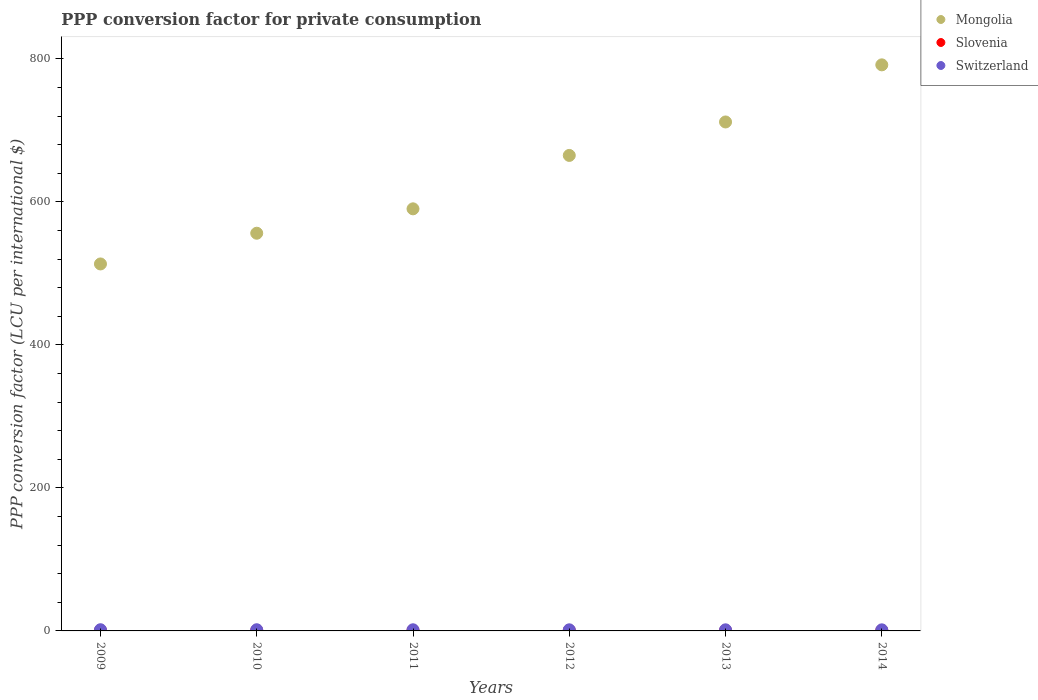What is the PPP conversion factor for private consumption in Slovenia in 2012?
Offer a terse response. 0.68. Across all years, what is the maximum PPP conversion factor for private consumption in Mongolia?
Make the answer very short. 791.69. Across all years, what is the minimum PPP conversion factor for private consumption in Slovenia?
Keep it short and to the point. 0.67. What is the total PPP conversion factor for private consumption in Mongolia in the graph?
Provide a succinct answer. 3828.33. What is the difference between the PPP conversion factor for private consumption in Switzerland in 2009 and that in 2010?
Give a very brief answer. 0.01. What is the difference between the PPP conversion factor for private consumption in Mongolia in 2013 and the PPP conversion factor for private consumption in Switzerland in 2012?
Give a very brief answer. 710.27. What is the average PPP conversion factor for private consumption in Slovenia per year?
Keep it short and to the point. 0.68. In the year 2011, what is the difference between the PPP conversion factor for private consumption in Switzerland and PPP conversion factor for private consumption in Slovenia?
Your answer should be very brief. 0.9. What is the ratio of the PPP conversion factor for private consumption in Switzerland in 2012 to that in 2014?
Offer a very short reply. 1.02. Is the PPP conversion factor for private consumption in Switzerland in 2010 less than that in 2013?
Keep it short and to the point. No. Is the difference between the PPP conversion factor for private consumption in Switzerland in 2010 and 2014 greater than the difference between the PPP conversion factor for private consumption in Slovenia in 2010 and 2014?
Your answer should be very brief. Yes. What is the difference between the highest and the second highest PPP conversion factor for private consumption in Mongolia?
Your answer should be compact. 79.87. What is the difference between the highest and the lowest PPP conversion factor for private consumption in Slovenia?
Provide a short and direct response. 0.04. Is the sum of the PPP conversion factor for private consumption in Mongolia in 2010 and 2014 greater than the maximum PPP conversion factor for private consumption in Switzerland across all years?
Your answer should be compact. Yes. Is it the case that in every year, the sum of the PPP conversion factor for private consumption in Slovenia and PPP conversion factor for private consumption in Switzerland  is greater than the PPP conversion factor for private consumption in Mongolia?
Offer a very short reply. No. How many dotlines are there?
Your answer should be compact. 3. How many years are there in the graph?
Provide a short and direct response. 6. Does the graph contain any zero values?
Provide a succinct answer. No. Does the graph contain grids?
Provide a short and direct response. No. Where does the legend appear in the graph?
Make the answer very short. Top right. How many legend labels are there?
Offer a very short reply. 3. What is the title of the graph?
Your answer should be compact. PPP conversion factor for private consumption. What is the label or title of the Y-axis?
Your answer should be very brief. PPP conversion factor (LCU per international $). What is the PPP conversion factor (LCU per international $) of Mongolia in 2009?
Keep it short and to the point. 513.24. What is the PPP conversion factor (LCU per international $) of Slovenia in 2009?
Provide a succinct answer. 0.7. What is the PPP conversion factor (LCU per international $) of Switzerland in 2009?
Provide a succinct answer. 1.67. What is the PPP conversion factor (LCU per international $) in Mongolia in 2010?
Your response must be concise. 556.21. What is the PPP conversion factor (LCU per international $) of Slovenia in 2010?
Keep it short and to the point. 0.7. What is the PPP conversion factor (LCU per international $) of Switzerland in 2010?
Offer a very short reply. 1.66. What is the PPP conversion factor (LCU per international $) in Mongolia in 2011?
Your answer should be compact. 590.33. What is the PPP conversion factor (LCU per international $) of Slovenia in 2011?
Keep it short and to the point. 0.69. What is the PPP conversion factor (LCU per international $) of Switzerland in 2011?
Make the answer very short. 1.59. What is the PPP conversion factor (LCU per international $) in Mongolia in 2012?
Your answer should be very brief. 665.03. What is the PPP conversion factor (LCU per international $) in Slovenia in 2012?
Offer a very short reply. 0.68. What is the PPP conversion factor (LCU per international $) of Switzerland in 2012?
Provide a short and direct response. 1.55. What is the PPP conversion factor (LCU per international $) of Mongolia in 2013?
Offer a terse response. 711.82. What is the PPP conversion factor (LCU per international $) in Slovenia in 2013?
Your answer should be very brief. 0.67. What is the PPP conversion factor (LCU per international $) in Switzerland in 2013?
Provide a succinct answer. 1.54. What is the PPP conversion factor (LCU per international $) of Mongolia in 2014?
Your response must be concise. 791.69. What is the PPP conversion factor (LCU per international $) of Slovenia in 2014?
Ensure brevity in your answer.  0.67. What is the PPP conversion factor (LCU per international $) in Switzerland in 2014?
Your answer should be very brief. 1.52. Across all years, what is the maximum PPP conversion factor (LCU per international $) in Mongolia?
Ensure brevity in your answer.  791.69. Across all years, what is the maximum PPP conversion factor (LCU per international $) in Slovenia?
Your answer should be compact. 0.7. Across all years, what is the maximum PPP conversion factor (LCU per international $) in Switzerland?
Your answer should be very brief. 1.67. Across all years, what is the minimum PPP conversion factor (LCU per international $) in Mongolia?
Make the answer very short. 513.24. Across all years, what is the minimum PPP conversion factor (LCU per international $) of Slovenia?
Your response must be concise. 0.67. Across all years, what is the minimum PPP conversion factor (LCU per international $) of Switzerland?
Make the answer very short. 1.52. What is the total PPP conversion factor (LCU per international $) of Mongolia in the graph?
Your answer should be compact. 3828.33. What is the total PPP conversion factor (LCU per international $) of Slovenia in the graph?
Your response must be concise. 4.11. What is the total PPP conversion factor (LCU per international $) of Switzerland in the graph?
Your answer should be very brief. 9.52. What is the difference between the PPP conversion factor (LCU per international $) of Mongolia in 2009 and that in 2010?
Offer a very short reply. -42.97. What is the difference between the PPP conversion factor (LCU per international $) of Slovenia in 2009 and that in 2010?
Give a very brief answer. 0.01. What is the difference between the PPP conversion factor (LCU per international $) of Switzerland in 2009 and that in 2010?
Keep it short and to the point. 0.01. What is the difference between the PPP conversion factor (LCU per international $) in Mongolia in 2009 and that in 2011?
Provide a succinct answer. -77.09. What is the difference between the PPP conversion factor (LCU per international $) of Slovenia in 2009 and that in 2011?
Provide a short and direct response. 0.02. What is the difference between the PPP conversion factor (LCU per international $) in Switzerland in 2009 and that in 2011?
Your answer should be very brief. 0.08. What is the difference between the PPP conversion factor (LCU per international $) of Mongolia in 2009 and that in 2012?
Keep it short and to the point. -151.78. What is the difference between the PPP conversion factor (LCU per international $) in Slovenia in 2009 and that in 2012?
Offer a very short reply. 0.03. What is the difference between the PPP conversion factor (LCU per international $) in Switzerland in 2009 and that in 2012?
Provide a short and direct response. 0.11. What is the difference between the PPP conversion factor (LCU per international $) in Mongolia in 2009 and that in 2013?
Offer a very short reply. -198.58. What is the difference between the PPP conversion factor (LCU per international $) in Slovenia in 2009 and that in 2013?
Ensure brevity in your answer.  0.03. What is the difference between the PPP conversion factor (LCU per international $) in Switzerland in 2009 and that in 2013?
Provide a short and direct response. 0.12. What is the difference between the PPP conversion factor (LCU per international $) of Mongolia in 2009 and that in 2014?
Provide a succinct answer. -278.45. What is the difference between the PPP conversion factor (LCU per international $) in Slovenia in 2009 and that in 2014?
Offer a very short reply. 0.04. What is the difference between the PPP conversion factor (LCU per international $) in Mongolia in 2010 and that in 2011?
Provide a succinct answer. -34.12. What is the difference between the PPP conversion factor (LCU per international $) in Slovenia in 2010 and that in 2011?
Ensure brevity in your answer.  0.01. What is the difference between the PPP conversion factor (LCU per international $) of Switzerland in 2010 and that in 2011?
Your answer should be compact. 0.07. What is the difference between the PPP conversion factor (LCU per international $) of Mongolia in 2010 and that in 2012?
Offer a very short reply. -108.81. What is the difference between the PPP conversion factor (LCU per international $) of Slovenia in 2010 and that in 2012?
Provide a short and direct response. 0.02. What is the difference between the PPP conversion factor (LCU per international $) of Switzerland in 2010 and that in 2012?
Make the answer very short. 0.11. What is the difference between the PPP conversion factor (LCU per international $) in Mongolia in 2010 and that in 2013?
Give a very brief answer. -155.61. What is the difference between the PPP conversion factor (LCU per international $) in Slovenia in 2010 and that in 2013?
Provide a succinct answer. 0.03. What is the difference between the PPP conversion factor (LCU per international $) in Switzerland in 2010 and that in 2013?
Keep it short and to the point. 0.12. What is the difference between the PPP conversion factor (LCU per international $) of Mongolia in 2010 and that in 2014?
Offer a very short reply. -235.48. What is the difference between the PPP conversion factor (LCU per international $) of Slovenia in 2010 and that in 2014?
Make the answer very short. 0.03. What is the difference between the PPP conversion factor (LCU per international $) of Switzerland in 2010 and that in 2014?
Your answer should be very brief. 0.14. What is the difference between the PPP conversion factor (LCU per international $) in Mongolia in 2011 and that in 2012?
Offer a very short reply. -74.7. What is the difference between the PPP conversion factor (LCU per international $) in Slovenia in 2011 and that in 2012?
Give a very brief answer. 0.01. What is the difference between the PPP conversion factor (LCU per international $) of Switzerland in 2011 and that in 2012?
Offer a very short reply. 0.03. What is the difference between the PPP conversion factor (LCU per international $) in Mongolia in 2011 and that in 2013?
Provide a short and direct response. -121.49. What is the difference between the PPP conversion factor (LCU per international $) in Slovenia in 2011 and that in 2013?
Your answer should be very brief. 0.01. What is the difference between the PPP conversion factor (LCU per international $) of Switzerland in 2011 and that in 2013?
Provide a short and direct response. 0.05. What is the difference between the PPP conversion factor (LCU per international $) in Mongolia in 2011 and that in 2014?
Your answer should be very brief. -201.36. What is the difference between the PPP conversion factor (LCU per international $) of Slovenia in 2011 and that in 2014?
Ensure brevity in your answer.  0.02. What is the difference between the PPP conversion factor (LCU per international $) of Switzerland in 2011 and that in 2014?
Keep it short and to the point. 0.07. What is the difference between the PPP conversion factor (LCU per international $) of Mongolia in 2012 and that in 2013?
Make the answer very short. -46.8. What is the difference between the PPP conversion factor (LCU per international $) in Slovenia in 2012 and that in 2013?
Offer a terse response. 0. What is the difference between the PPP conversion factor (LCU per international $) in Switzerland in 2012 and that in 2013?
Provide a succinct answer. 0.01. What is the difference between the PPP conversion factor (LCU per international $) of Mongolia in 2012 and that in 2014?
Offer a terse response. -126.67. What is the difference between the PPP conversion factor (LCU per international $) in Slovenia in 2012 and that in 2014?
Provide a short and direct response. 0.01. What is the difference between the PPP conversion factor (LCU per international $) of Switzerland in 2012 and that in 2014?
Offer a terse response. 0.04. What is the difference between the PPP conversion factor (LCU per international $) of Mongolia in 2013 and that in 2014?
Keep it short and to the point. -79.87. What is the difference between the PPP conversion factor (LCU per international $) of Slovenia in 2013 and that in 2014?
Provide a succinct answer. 0.01. What is the difference between the PPP conversion factor (LCU per international $) in Switzerland in 2013 and that in 2014?
Your response must be concise. 0.03. What is the difference between the PPP conversion factor (LCU per international $) in Mongolia in 2009 and the PPP conversion factor (LCU per international $) in Slovenia in 2010?
Offer a very short reply. 512.54. What is the difference between the PPP conversion factor (LCU per international $) in Mongolia in 2009 and the PPP conversion factor (LCU per international $) in Switzerland in 2010?
Keep it short and to the point. 511.58. What is the difference between the PPP conversion factor (LCU per international $) of Slovenia in 2009 and the PPP conversion factor (LCU per international $) of Switzerland in 2010?
Make the answer very short. -0.95. What is the difference between the PPP conversion factor (LCU per international $) in Mongolia in 2009 and the PPP conversion factor (LCU per international $) in Slovenia in 2011?
Keep it short and to the point. 512.56. What is the difference between the PPP conversion factor (LCU per international $) in Mongolia in 2009 and the PPP conversion factor (LCU per international $) in Switzerland in 2011?
Your response must be concise. 511.66. What is the difference between the PPP conversion factor (LCU per international $) in Slovenia in 2009 and the PPP conversion factor (LCU per international $) in Switzerland in 2011?
Make the answer very short. -0.88. What is the difference between the PPP conversion factor (LCU per international $) of Mongolia in 2009 and the PPP conversion factor (LCU per international $) of Slovenia in 2012?
Provide a succinct answer. 512.57. What is the difference between the PPP conversion factor (LCU per international $) of Mongolia in 2009 and the PPP conversion factor (LCU per international $) of Switzerland in 2012?
Offer a very short reply. 511.69. What is the difference between the PPP conversion factor (LCU per international $) of Slovenia in 2009 and the PPP conversion factor (LCU per international $) of Switzerland in 2012?
Your answer should be very brief. -0.85. What is the difference between the PPP conversion factor (LCU per international $) in Mongolia in 2009 and the PPP conversion factor (LCU per international $) in Slovenia in 2013?
Your answer should be compact. 512.57. What is the difference between the PPP conversion factor (LCU per international $) in Mongolia in 2009 and the PPP conversion factor (LCU per international $) in Switzerland in 2013?
Your answer should be very brief. 511.7. What is the difference between the PPP conversion factor (LCU per international $) in Slovenia in 2009 and the PPP conversion factor (LCU per international $) in Switzerland in 2013?
Your answer should be very brief. -0.84. What is the difference between the PPP conversion factor (LCU per international $) of Mongolia in 2009 and the PPP conversion factor (LCU per international $) of Slovenia in 2014?
Ensure brevity in your answer.  512.58. What is the difference between the PPP conversion factor (LCU per international $) of Mongolia in 2009 and the PPP conversion factor (LCU per international $) of Switzerland in 2014?
Offer a very short reply. 511.73. What is the difference between the PPP conversion factor (LCU per international $) in Slovenia in 2009 and the PPP conversion factor (LCU per international $) in Switzerland in 2014?
Your answer should be very brief. -0.81. What is the difference between the PPP conversion factor (LCU per international $) in Mongolia in 2010 and the PPP conversion factor (LCU per international $) in Slovenia in 2011?
Offer a very short reply. 555.53. What is the difference between the PPP conversion factor (LCU per international $) in Mongolia in 2010 and the PPP conversion factor (LCU per international $) in Switzerland in 2011?
Offer a very short reply. 554.63. What is the difference between the PPP conversion factor (LCU per international $) in Slovenia in 2010 and the PPP conversion factor (LCU per international $) in Switzerland in 2011?
Provide a short and direct response. -0.89. What is the difference between the PPP conversion factor (LCU per international $) of Mongolia in 2010 and the PPP conversion factor (LCU per international $) of Slovenia in 2012?
Your answer should be compact. 555.54. What is the difference between the PPP conversion factor (LCU per international $) in Mongolia in 2010 and the PPP conversion factor (LCU per international $) in Switzerland in 2012?
Ensure brevity in your answer.  554.66. What is the difference between the PPP conversion factor (LCU per international $) in Slovenia in 2010 and the PPP conversion factor (LCU per international $) in Switzerland in 2012?
Your response must be concise. -0.85. What is the difference between the PPP conversion factor (LCU per international $) in Mongolia in 2010 and the PPP conversion factor (LCU per international $) in Slovenia in 2013?
Offer a very short reply. 555.54. What is the difference between the PPP conversion factor (LCU per international $) of Mongolia in 2010 and the PPP conversion factor (LCU per international $) of Switzerland in 2013?
Keep it short and to the point. 554.67. What is the difference between the PPP conversion factor (LCU per international $) in Slovenia in 2010 and the PPP conversion factor (LCU per international $) in Switzerland in 2013?
Give a very brief answer. -0.84. What is the difference between the PPP conversion factor (LCU per international $) of Mongolia in 2010 and the PPP conversion factor (LCU per international $) of Slovenia in 2014?
Your answer should be very brief. 555.55. What is the difference between the PPP conversion factor (LCU per international $) of Mongolia in 2010 and the PPP conversion factor (LCU per international $) of Switzerland in 2014?
Offer a very short reply. 554.7. What is the difference between the PPP conversion factor (LCU per international $) in Slovenia in 2010 and the PPP conversion factor (LCU per international $) in Switzerland in 2014?
Offer a very short reply. -0.82. What is the difference between the PPP conversion factor (LCU per international $) of Mongolia in 2011 and the PPP conversion factor (LCU per international $) of Slovenia in 2012?
Your response must be concise. 589.65. What is the difference between the PPP conversion factor (LCU per international $) of Mongolia in 2011 and the PPP conversion factor (LCU per international $) of Switzerland in 2012?
Ensure brevity in your answer.  588.78. What is the difference between the PPP conversion factor (LCU per international $) of Slovenia in 2011 and the PPP conversion factor (LCU per international $) of Switzerland in 2012?
Keep it short and to the point. -0.87. What is the difference between the PPP conversion factor (LCU per international $) of Mongolia in 2011 and the PPP conversion factor (LCU per international $) of Slovenia in 2013?
Offer a very short reply. 589.66. What is the difference between the PPP conversion factor (LCU per international $) in Mongolia in 2011 and the PPP conversion factor (LCU per international $) in Switzerland in 2013?
Keep it short and to the point. 588.79. What is the difference between the PPP conversion factor (LCU per international $) in Slovenia in 2011 and the PPP conversion factor (LCU per international $) in Switzerland in 2013?
Make the answer very short. -0.85. What is the difference between the PPP conversion factor (LCU per international $) in Mongolia in 2011 and the PPP conversion factor (LCU per international $) in Slovenia in 2014?
Make the answer very short. 589.66. What is the difference between the PPP conversion factor (LCU per international $) in Mongolia in 2011 and the PPP conversion factor (LCU per international $) in Switzerland in 2014?
Provide a short and direct response. 588.81. What is the difference between the PPP conversion factor (LCU per international $) of Slovenia in 2011 and the PPP conversion factor (LCU per international $) of Switzerland in 2014?
Your response must be concise. -0.83. What is the difference between the PPP conversion factor (LCU per international $) in Mongolia in 2012 and the PPP conversion factor (LCU per international $) in Slovenia in 2013?
Your response must be concise. 664.35. What is the difference between the PPP conversion factor (LCU per international $) in Mongolia in 2012 and the PPP conversion factor (LCU per international $) in Switzerland in 2013?
Your answer should be very brief. 663.49. What is the difference between the PPP conversion factor (LCU per international $) in Slovenia in 2012 and the PPP conversion factor (LCU per international $) in Switzerland in 2013?
Your answer should be very brief. -0.86. What is the difference between the PPP conversion factor (LCU per international $) in Mongolia in 2012 and the PPP conversion factor (LCU per international $) in Slovenia in 2014?
Make the answer very short. 664.36. What is the difference between the PPP conversion factor (LCU per international $) in Mongolia in 2012 and the PPP conversion factor (LCU per international $) in Switzerland in 2014?
Your answer should be compact. 663.51. What is the difference between the PPP conversion factor (LCU per international $) in Slovenia in 2012 and the PPP conversion factor (LCU per international $) in Switzerland in 2014?
Give a very brief answer. -0.84. What is the difference between the PPP conversion factor (LCU per international $) of Mongolia in 2013 and the PPP conversion factor (LCU per international $) of Slovenia in 2014?
Your answer should be compact. 711.15. What is the difference between the PPP conversion factor (LCU per international $) of Mongolia in 2013 and the PPP conversion factor (LCU per international $) of Switzerland in 2014?
Your response must be concise. 710.31. What is the difference between the PPP conversion factor (LCU per international $) in Slovenia in 2013 and the PPP conversion factor (LCU per international $) in Switzerland in 2014?
Make the answer very short. -0.84. What is the average PPP conversion factor (LCU per international $) of Mongolia per year?
Offer a terse response. 638.05. What is the average PPP conversion factor (LCU per international $) in Slovenia per year?
Provide a succinct answer. 0.69. What is the average PPP conversion factor (LCU per international $) in Switzerland per year?
Ensure brevity in your answer.  1.59. In the year 2009, what is the difference between the PPP conversion factor (LCU per international $) of Mongolia and PPP conversion factor (LCU per international $) of Slovenia?
Provide a short and direct response. 512.54. In the year 2009, what is the difference between the PPP conversion factor (LCU per international $) in Mongolia and PPP conversion factor (LCU per international $) in Switzerland?
Make the answer very short. 511.58. In the year 2009, what is the difference between the PPP conversion factor (LCU per international $) of Slovenia and PPP conversion factor (LCU per international $) of Switzerland?
Your answer should be compact. -0.96. In the year 2010, what is the difference between the PPP conversion factor (LCU per international $) in Mongolia and PPP conversion factor (LCU per international $) in Slovenia?
Ensure brevity in your answer.  555.51. In the year 2010, what is the difference between the PPP conversion factor (LCU per international $) in Mongolia and PPP conversion factor (LCU per international $) in Switzerland?
Your answer should be compact. 554.56. In the year 2010, what is the difference between the PPP conversion factor (LCU per international $) in Slovenia and PPP conversion factor (LCU per international $) in Switzerland?
Give a very brief answer. -0.96. In the year 2011, what is the difference between the PPP conversion factor (LCU per international $) in Mongolia and PPP conversion factor (LCU per international $) in Slovenia?
Provide a short and direct response. 589.64. In the year 2011, what is the difference between the PPP conversion factor (LCU per international $) of Mongolia and PPP conversion factor (LCU per international $) of Switzerland?
Offer a very short reply. 588.74. In the year 2011, what is the difference between the PPP conversion factor (LCU per international $) in Slovenia and PPP conversion factor (LCU per international $) in Switzerland?
Keep it short and to the point. -0.9. In the year 2012, what is the difference between the PPP conversion factor (LCU per international $) in Mongolia and PPP conversion factor (LCU per international $) in Slovenia?
Ensure brevity in your answer.  664.35. In the year 2012, what is the difference between the PPP conversion factor (LCU per international $) in Mongolia and PPP conversion factor (LCU per international $) in Switzerland?
Keep it short and to the point. 663.47. In the year 2012, what is the difference between the PPP conversion factor (LCU per international $) in Slovenia and PPP conversion factor (LCU per international $) in Switzerland?
Provide a succinct answer. -0.88. In the year 2013, what is the difference between the PPP conversion factor (LCU per international $) of Mongolia and PPP conversion factor (LCU per international $) of Slovenia?
Your answer should be very brief. 711.15. In the year 2013, what is the difference between the PPP conversion factor (LCU per international $) of Mongolia and PPP conversion factor (LCU per international $) of Switzerland?
Your answer should be very brief. 710.28. In the year 2013, what is the difference between the PPP conversion factor (LCU per international $) of Slovenia and PPP conversion factor (LCU per international $) of Switzerland?
Offer a terse response. -0.87. In the year 2014, what is the difference between the PPP conversion factor (LCU per international $) of Mongolia and PPP conversion factor (LCU per international $) of Slovenia?
Provide a succinct answer. 791.02. In the year 2014, what is the difference between the PPP conversion factor (LCU per international $) of Mongolia and PPP conversion factor (LCU per international $) of Switzerland?
Ensure brevity in your answer.  790.18. In the year 2014, what is the difference between the PPP conversion factor (LCU per international $) of Slovenia and PPP conversion factor (LCU per international $) of Switzerland?
Your response must be concise. -0.85. What is the ratio of the PPP conversion factor (LCU per international $) of Mongolia in 2009 to that in 2010?
Ensure brevity in your answer.  0.92. What is the ratio of the PPP conversion factor (LCU per international $) of Slovenia in 2009 to that in 2010?
Offer a terse response. 1.01. What is the ratio of the PPP conversion factor (LCU per international $) in Mongolia in 2009 to that in 2011?
Keep it short and to the point. 0.87. What is the ratio of the PPP conversion factor (LCU per international $) in Slovenia in 2009 to that in 2011?
Offer a terse response. 1.03. What is the ratio of the PPP conversion factor (LCU per international $) of Switzerland in 2009 to that in 2011?
Provide a succinct answer. 1.05. What is the ratio of the PPP conversion factor (LCU per international $) of Mongolia in 2009 to that in 2012?
Provide a succinct answer. 0.77. What is the ratio of the PPP conversion factor (LCU per international $) in Switzerland in 2009 to that in 2012?
Your response must be concise. 1.07. What is the ratio of the PPP conversion factor (LCU per international $) in Mongolia in 2009 to that in 2013?
Ensure brevity in your answer.  0.72. What is the ratio of the PPP conversion factor (LCU per international $) of Slovenia in 2009 to that in 2013?
Keep it short and to the point. 1.05. What is the ratio of the PPP conversion factor (LCU per international $) of Switzerland in 2009 to that in 2013?
Your answer should be compact. 1.08. What is the ratio of the PPP conversion factor (LCU per international $) of Mongolia in 2009 to that in 2014?
Provide a short and direct response. 0.65. What is the ratio of the PPP conversion factor (LCU per international $) in Slovenia in 2009 to that in 2014?
Your answer should be very brief. 1.05. What is the ratio of the PPP conversion factor (LCU per international $) of Switzerland in 2009 to that in 2014?
Your answer should be compact. 1.1. What is the ratio of the PPP conversion factor (LCU per international $) in Mongolia in 2010 to that in 2011?
Your answer should be compact. 0.94. What is the ratio of the PPP conversion factor (LCU per international $) in Slovenia in 2010 to that in 2011?
Ensure brevity in your answer.  1.02. What is the ratio of the PPP conversion factor (LCU per international $) of Switzerland in 2010 to that in 2011?
Provide a succinct answer. 1.04. What is the ratio of the PPP conversion factor (LCU per international $) in Mongolia in 2010 to that in 2012?
Your answer should be compact. 0.84. What is the ratio of the PPP conversion factor (LCU per international $) of Slovenia in 2010 to that in 2012?
Provide a succinct answer. 1.03. What is the ratio of the PPP conversion factor (LCU per international $) in Switzerland in 2010 to that in 2012?
Provide a succinct answer. 1.07. What is the ratio of the PPP conversion factor (LCU per international $) of Mongolia in 2010 to that in 2013?
Make the answer very short. 0.78. What is the ratio of the PPP conversion factor (LCU per international $) in Slovenia in 2010 to that in 2013?
Your answer should be compact. 1.04. What is the ratio of the PPP conversion factor (LCU per international $) in Switzerland in 2010 to that in 2013?
Your answer should be compact. 1.08. What is the ratio of the PPP conversion factor (LCU per international $) of Mongolia in 2010 to that in 2014?
Make the answer very short. 0.7. What is the ratio of the PPP conversion factor (LCU per international $) of Slovenia in 2010 to that in 2014?
Your response must be concise. 1.05. What is the ratio of the PPP conversion factor (LCU per international $) in Switzerland in 2010 to that in 2014?
Your answer should be compact. 1.09. What is the ratio of the PPP conversion factor (LCU per international $) in Mongolia in 2011 to that in 2012?
Your answer should be compact. 0.89. What is the ratio of the PPP conversion factor (LCU per international $) of Switzerland in 2011 to that in 2012?
Provide a succinct answer. 1.02. What is the ratio of the PPP conversion factor (LCU per international $) in Mongolia in 2011 to that in 2013?
Keep it short and to the point. 0.83. What is the ratio of the PPP conversion factor (LCU per international $) in Slovenia in 2011 to that in 2013?
Give a very brief answer. 1.02. What is the ratio of the PPP conversion factor (LCU per international $) in Switzerland in 2011 to that in 2013?
Make the answer very short. 1.03. What is the ratio of the PPP conversion factor (LCU per international $) of Mongolia in 2011 to that in 2014?
Provide a short and direct response. 0.75. What is the ratio of the PPP conversion factor (LCU per international $) of Switzerland in 2011 to that in 2014?
Give a very brief answer. 1.05. What is the ratio of the PPP conversion factor (LCU per international $) of Mongolia in 2012 to that in 2013?
Ensure brevity in your answer.  0.93. What is the ratio of the PPP conversion factor (LCU per international $) in Switzerland in 2012 to that in 2013?
Provide a short and direct response. 1.01. What is the ratio of the PPP conversion factor (LCU per international $) in Mongolia in 2012 to that in 2014?
Ensure brevity in your answer.  0.84. What is the ratio of the PPP conversion factor (LCU per international $) of Slovenia in 2012 to that in 2014?
Provide a short and direct response. 1.01. What is the ratio of the PPP conversion factor (LCU per international $) of Switzerland in 2012 to that in 2014?
Your response must be concise. 1.02. What is the ratio of the PPP conversion factor (LCU per international $) in Mongolia in 2013 to that in 2014?
Offer a very short reply. 0.9. What is the ratio of the PPP conversion factor (LCU per international $) of Slovenia in 2013 to that in 2014?
Your response must be concise. 1.01. What is the ratio of the PPP conversion factor (LCU per international $) in Switzerland in 2013 to that in 2014?
Make the answer very short. 1.02. What is the difference between the highest and the second highest PPP conversion factor (LCU per international $) of Mongolia?
Provide a short and direct response. 79.87. What is the difference between the highest and the second highest PPP conversion factor (LCU per international $) of Slovenia?
Offer a terse response. 0.01. What is the difference between the highest and the second highest PPP conversion factor (LCU per international $) of Switzerland?
Give a very brief answer. 0.01. What is the difference between the highest and the lowest PPP conversion factor (LCU per international $) of Mongolia?
Your answer should be compact. 278.45. What is the difference between the highest and the lowest PPP conversion factor (LCU per international $) of Slovenia?
Make the answer very short. 0.04. What is the difference between the highest and the lowest PPP conversion factor (LCU per international $) in Switzerland?
Offer a terse response. 0.15. 